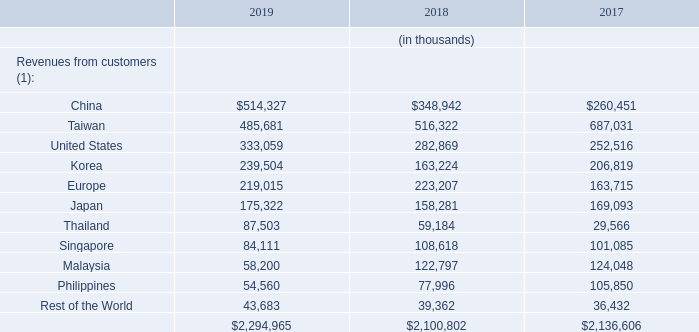Information as to Teradyne’s revenues by country is as follows:
(1) Revenues attributable to a country are based on location of customer site.
In 2019 and 2018, no single direct customer accounted for more than 10% of Teradyne’s consolidated revenues. In 2017, revenues from Taiwan Semiconductor Manufacturing Company Ltd. accounted for 13% of its consolidated revenues. Taiwan Semiconductor Manufacturing Company Ltd. is a customer of Teradyne’s Semiconductor Test segment. Teradyne estimates consolidated revenues driven by Huawei Technologies Co.Ltd. (“Huawei”), combining direct sales to that customer with sales to the customer’s OSATs, accounted for approximately 11% and 4% of its consolidated revenues in 2019 and 2018, respectively. Teradyne estimates consolidated revenues driven by another OEM customer, combining direct sales to that customer with sales to the customer’s OSATs (which include Taiwan Semiconductor Manufacturing Company Ltd.), accounted for approximately 10%, 13% and 22% of its consolidated revenues in 2019, 2018 and 2017, respectively.
What are the revenues from customers attributable to a country based on? Location of customer site. In which years is information as to Teradyne’s revenues by country provided? 2019, 2018, 2017. Which are the locations listed in the table? China, taiwan, united states, korea, europe, japan, thailand, singapore, malaysia, philippines, rest of the world. How many different locations are listed in the table? China##Taiwan##United States##Korea##Europe##Japan##Thailand##Singapore##Malaysia##Philippines##Rest of the World
Answer: 11. What was the change in Rest of the World in 2019 from 2018?
Answer scale should be: thousand. 43,683-39,362
Answer: 4321. What was the percentage change in Rest of the World in 2019 from 2018?
Answer scale should be: percent. (43,683-39,362)/39,362
Answer: 10.98. 